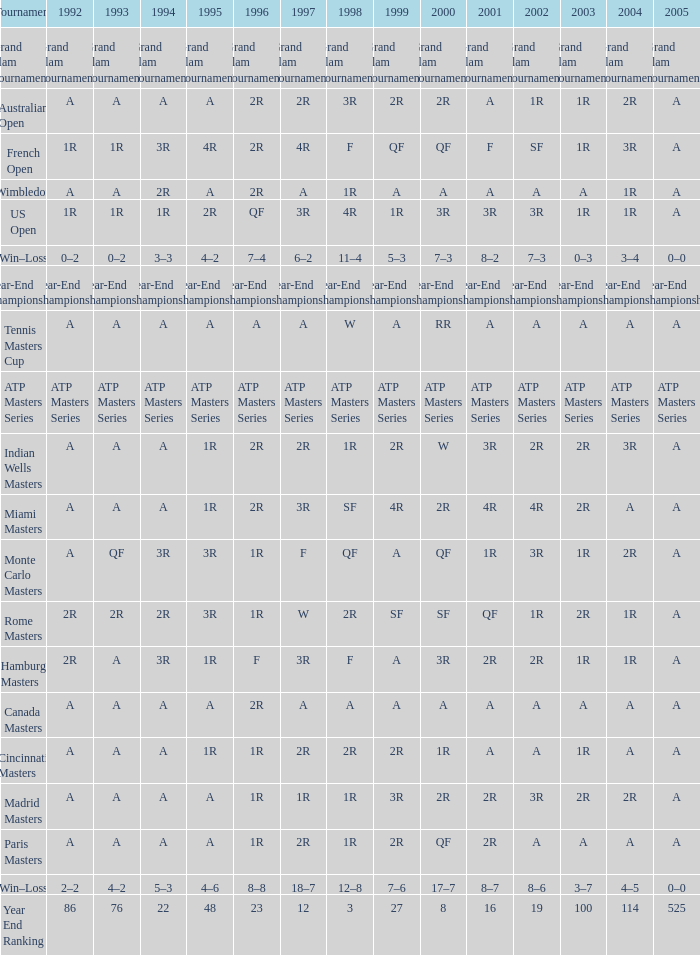What is 1992, when 1999 is "Year-End Championship"? Year-End Championship. 